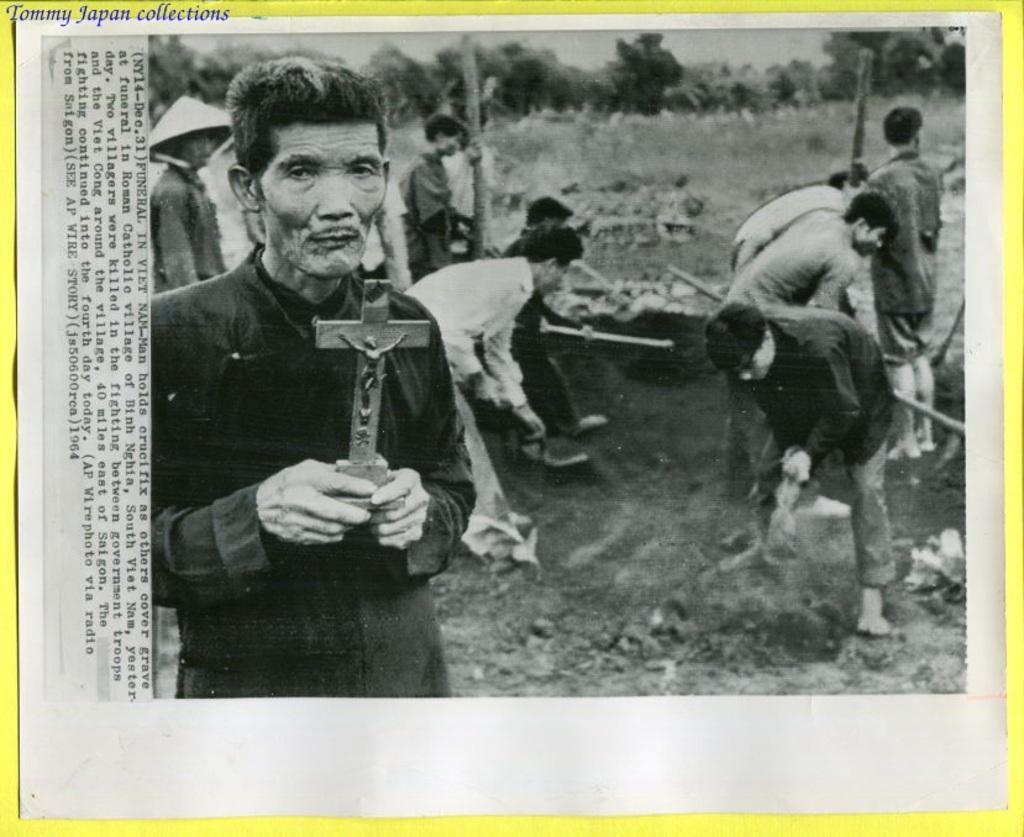In one or two sentences, can you explain what this image depicts? In this image I can see number of people and I can see all of them are holding few things. I can also see few trees in the background and on the left side of this image I can see something is written. I can also see this image is black and white in colour. 